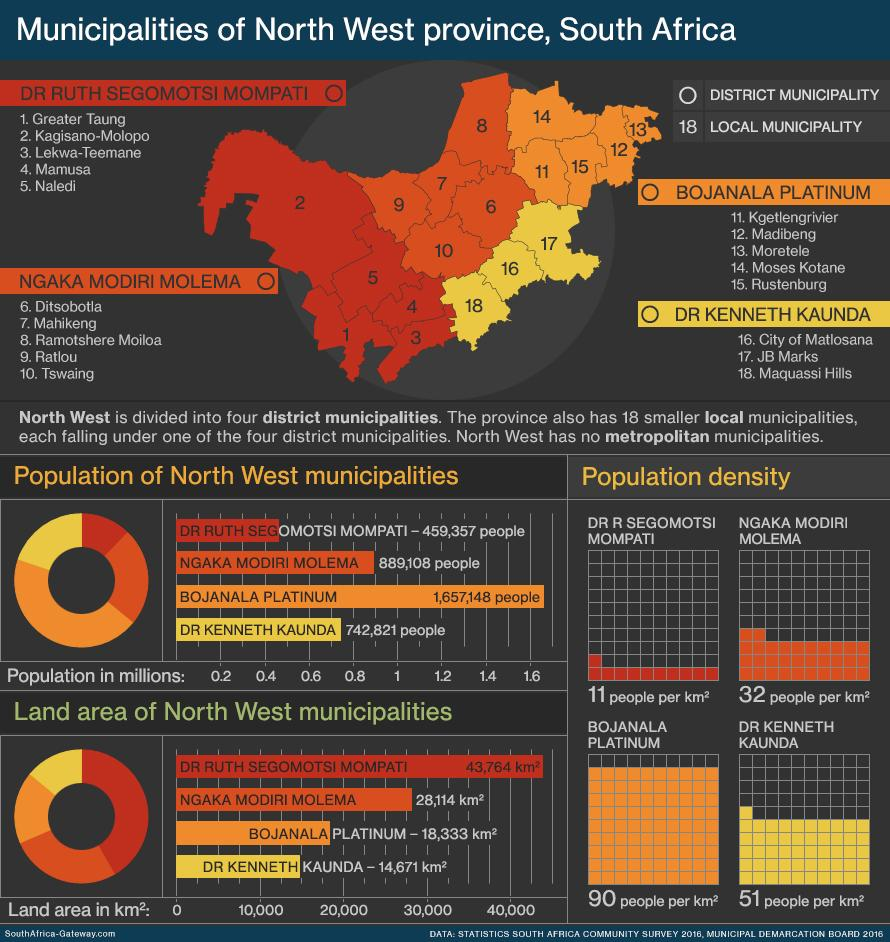Point out several critical features in this image. Bojanala Platinum District Municipality has the highest population among all district municipalities. The district municipality with the lowest population density is DR R Segomotsi Mompati. Bojanala Platinum is the district municipality that has the highest population density. 